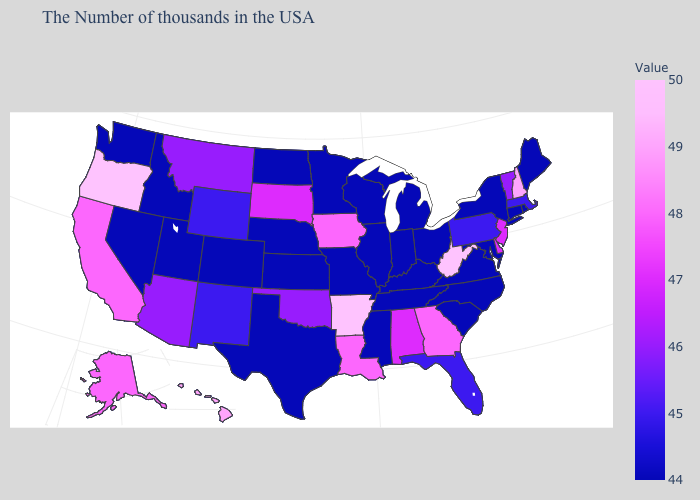Among the states that border New Jersey , does Delaware have the lowest value?
Short answer required. No. Does New York have the lowest value in the Northeast?
Give a very brief answer. Yes. Among the states that border Connecticut , which have the highest value?
Give a very brief answer. Massachusetts. Which states have the lowest value in the Northeast?
Concise answer only. Maine, Rhode Island, Connecticut, New York. Is the legend a continuous bar?
Keep it brief. Yes. Which states have the lowest value in the USA?
Concise answer only. Maine, Rhode Island, Connecticut, New York, Maryland, Virginia, North Carolina, South Carolina, Ohio, Michigan, Kentucky, Indiana, Tennessee, Wisconsin, Illinois, Mississippi, Missouri, Minnesota, Kansas, Nebraska, Texas, North Dakota, Colorado, Utah, Idaho, Nevada, Washington. Among the states that border New Jersey , does Pennsylvania have the lowest value?
Write a very short answer. No. 